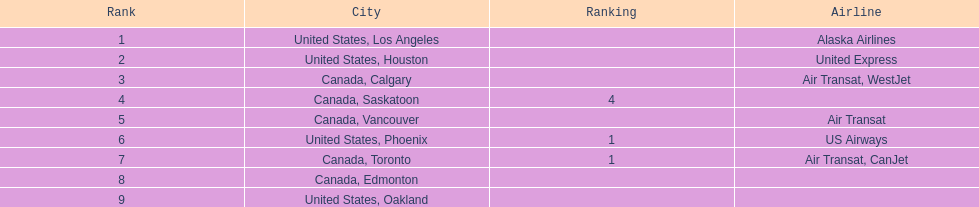Which airline handles the most passengers? Alaska Airlines. 